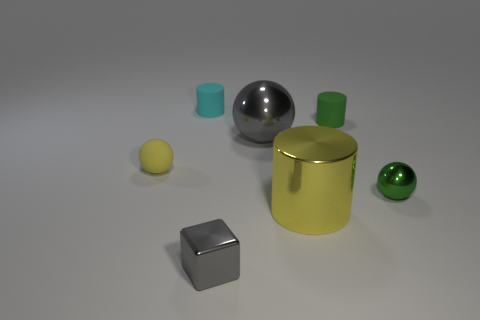Add 2 tiny red metal cubes. How many objects exist? 9 Subtract all cylinders. How many objects are left? 4 Add 4 brown shiny objects. How many brown shiny objects exist? 4 Subtract 0 blue cubes. How many objects are left? 7 Subtract all small cyan cylinders. Subtract all green rubber cylinders. How many objects are left? 5 Add 5 gray spheres. How many gray spheres are left? 6 